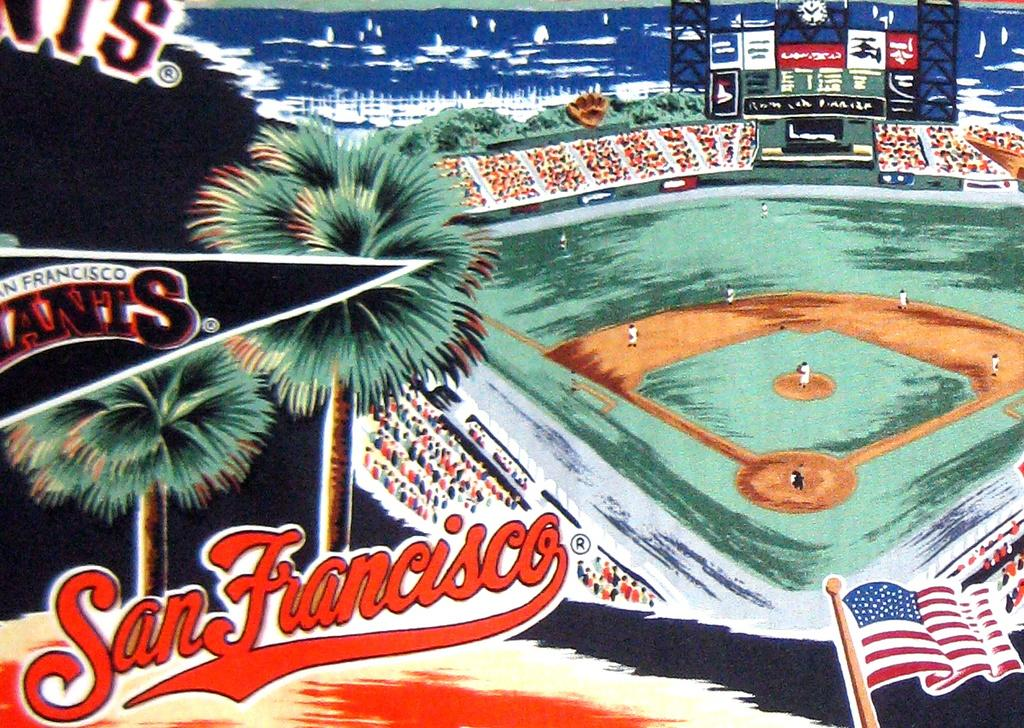<image>
Share a concise interpretation of the image provided. A poster showing a ball park and saying San Francisco. 